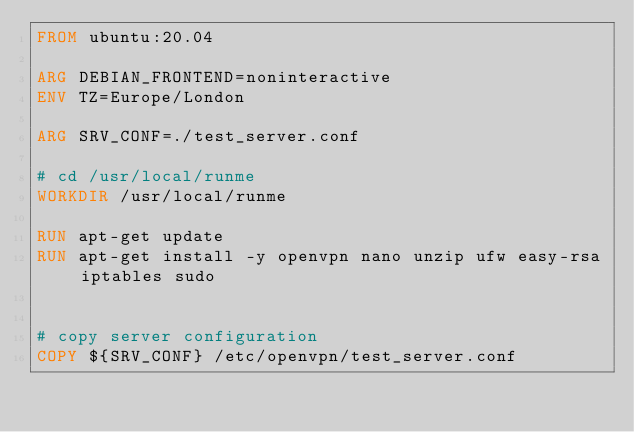<code> <loc_0><loc_0><loc_500><loc_500><_Dockerfile_>FROM ubuntu:20.04

ARG DEBIAN_FRONTEND=noninteractive
ENV TZ=Europe/London

ARG SRV_CONF=./test_server.conf

# cd /usr/local/runme
WORKDIR /usr/local/runme

RUN apt-get update
RUN apt-get install -y openvpn nano unzip ufw easy-rsa iptables sudo 


# copy server configuration
COPY ${SRV_CONF} /etc/openvpn/test_server.conf

	


</code> 